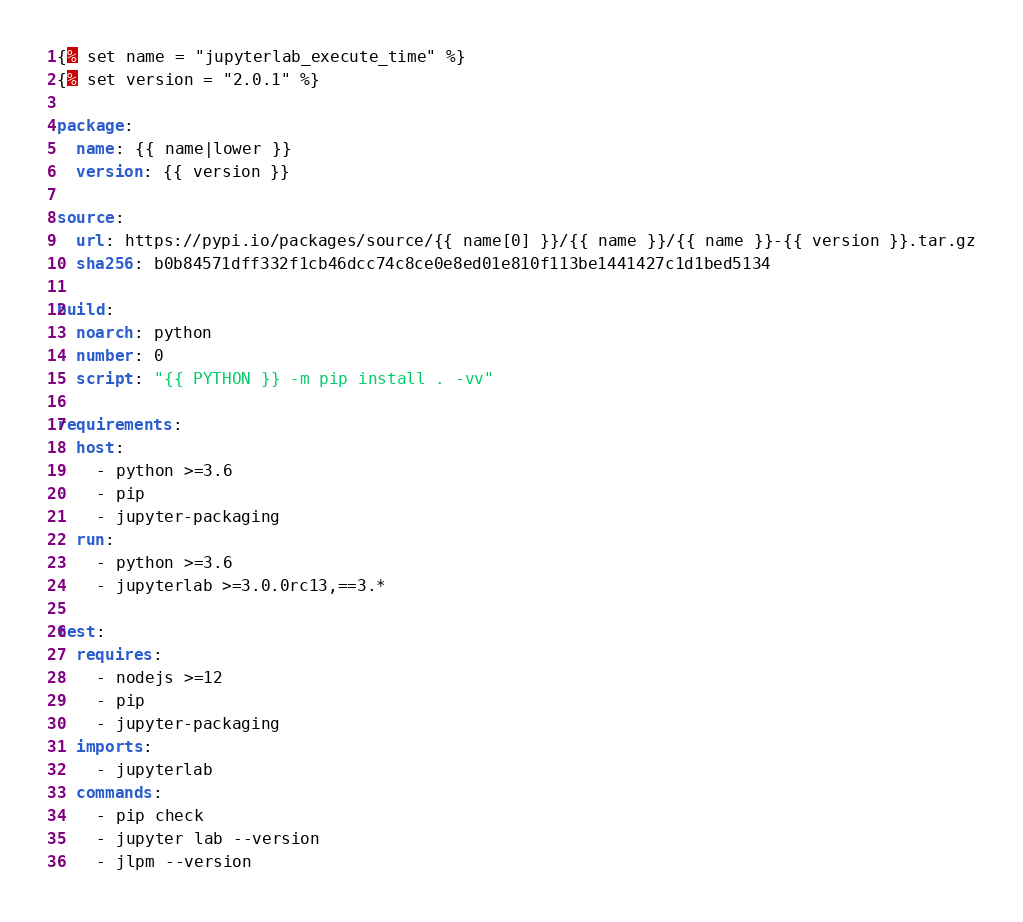Convert code to text. <code><loc_0><loc_0><loc_500><loc_500><_YAML_>{% set name = "jupyterlab_execute_time" %}
{% set version = "2.0.1" %}

package:
  name: {{ name|lower }}
  version: {{ version }}

source:
  url: https://pypi.io/packages/source/{{ name[0] }}/{{ name }}/{{ name }}-{{ version }}.tar.gz
  sha256: b0b84571dff332f1cb46dcc74c8ce0e8ed01e810f113be1441427c1d1bed5134

build:
  noarch: python
  number: 0
  script: "{{ PYTHON }} -m pip install . -vv"

requirements:
  host:
    - python >=3.6
    - pip
    - jupyter-packaging
  run:
    - python >=3.6
    - jupyterlab >=3.0.0rc13,==3.*

test:
  requires:
    - nodejs >=12
    - pip
    - jupyter-packaging
  imports:
    - jupyterlab
  commands:
    - pip check
    - jupyter lab --version
    - jlpm --version</code> 